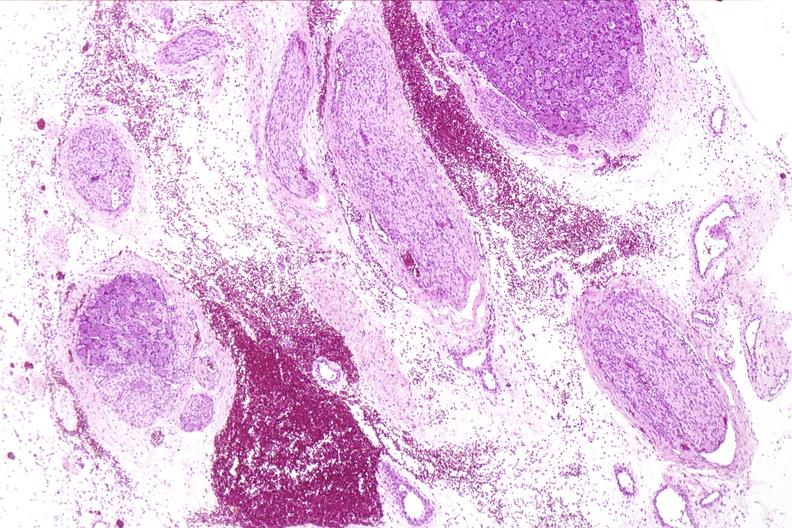does this image show neural tube defect, meningomyelocele?
Answer the question using a single word or phrase. Yes 